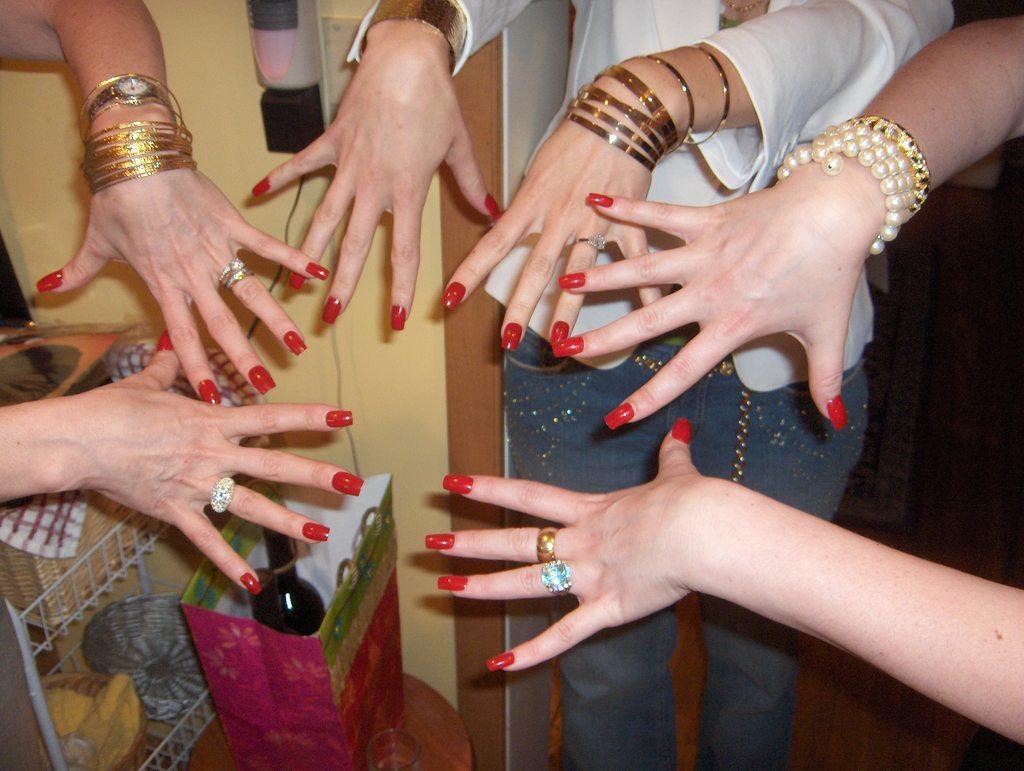Could you give a brief overview of what you see in this image? In this image I can see hands of few persons. I can see all of them are wearing bangles and few of them are wearing rings. I can see a metal rack with few wooden baskets in it, few wires, the cream colored wall and few other objects in the background. I can see all of the nails are painted with red colored nail polish. 